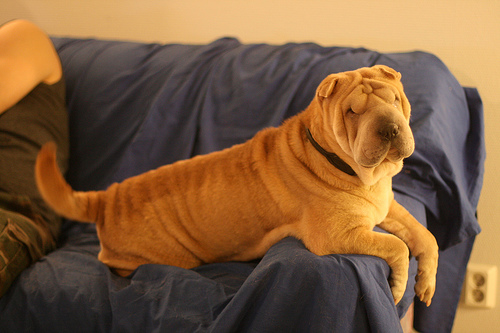How many dogs are there? 1 